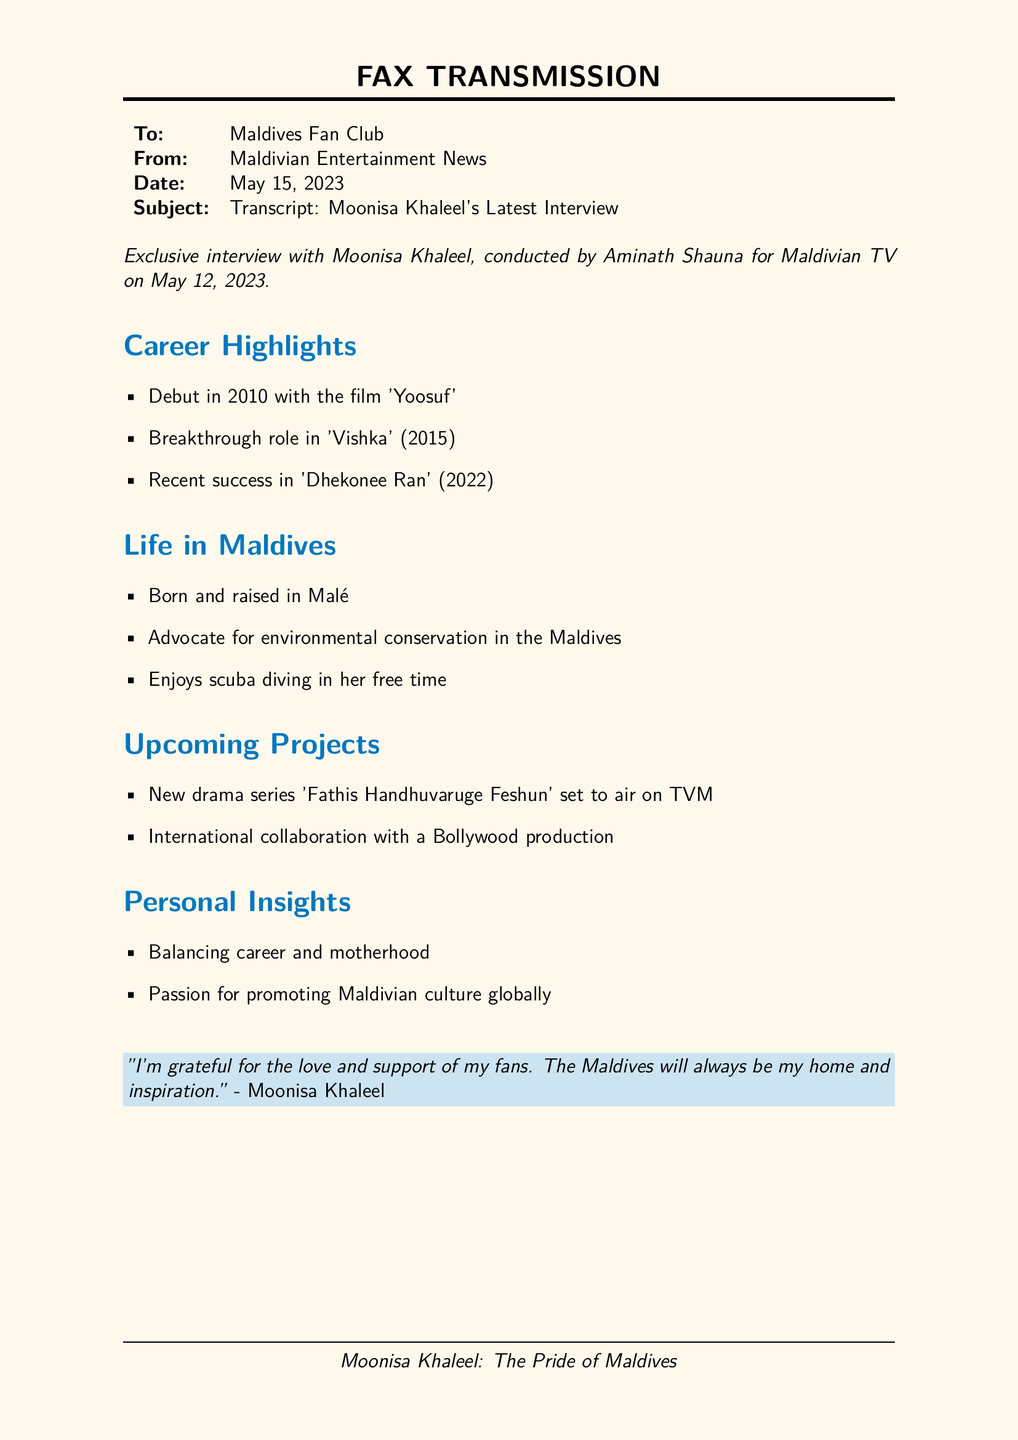What year did Moonisa Khaleel make her debut? Moonisa Khaleel made her debut in 2010, as mentioned in the career highlights.
Answer: 2010 What was Moonisa's breakthrough role? The breakthrough role mentioned in the document is 'Vishka' in 2015.
Answer: Vishka What is the title of Moonisa's recent success? The document states that her recent success is in 'Dhekonee Ran,' released in 2022.
Answer: Dhekonee Ran Where was Moonisa Khaleel born? According to the life in Maldives section, she was born and raised in Malé.
Answer: Malé What cause does Moonisa advocate for? She is noted as an advocate for environmental conservation in the Maldives.
Answer: Environmental conservation What is the title of her upcoming drama series? The upcoming drama series is titled 'Fathis Handhuvaruge Feshun.'
Answer: Fathis Handhuvaruge Feshun What is stated about balancing her career? The personal insights section mentions that she discusses balancing career and motherhood.
Answer: Career and motherhood Who conducted the interview? The interview was conducted by Aminath Shauna.
Answer: Aminath Shauna What is the document type? The document is a fax transmission.
Answer: Fax transmission 